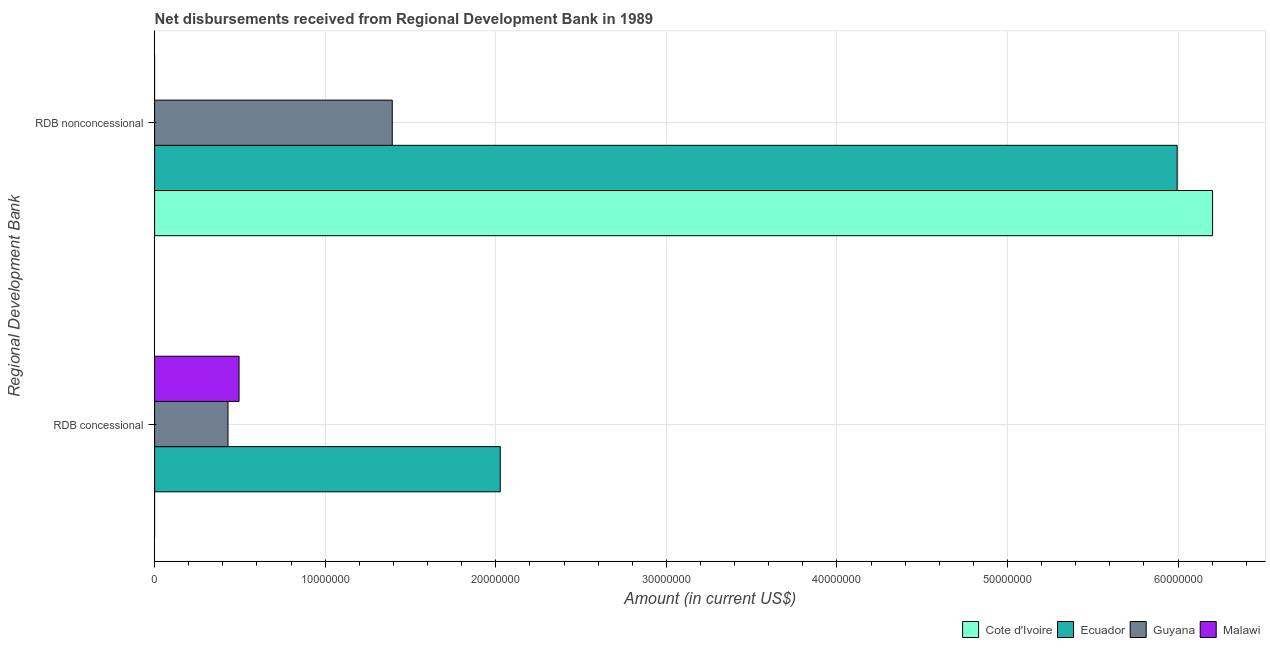Are the number of bars per tick equal to the number of legend labels?
Provide a short and direct response. No. Are the number of bars on each tick of the Y-axis equal?
Make the answer very short. Yes. What is the label of the 1st group of bars from the top?
Give a very brief answer. RDB nonconcessional. What is the net non concessional disbursements from rdb in Guyana?
Offer a very short reply. 1.39e+07. Across all countries, what is the maximum net non concessional disbursements from rdb?
Keep it short and to the point. 6.20e+07. In which country was the net concessional disbursements from rdb maximum?
Offer a very short reply. Ecuador. What is the total net non concessional disbursements from rdb in the graph?
Offer a very short reply. 1.36e+08. What is the difference between the net non concessional disbursements from rdb in Ecuador and that in Cote d'Ivoire?
Provide a short and direct response. -2.08e+06. What is the difference between the net concessional disbursements from rdb in Guyana and the net non concessional disbursements from rdb in Cote d'Ivoire?
Give a very brief answer. -5.77e+07. What is the average net concessional disbursements from rdb per country?
Offer a very short reply. 7.38e+06. What is the difference between the net non concessional disbursements from rdb and net concessional disbursements from rdb in Guyana?
Offer a terse response. 9.63e+06. What is the ratio of the net non concessional disbursements from rdb in Ecuador to that in Guyana?
Give a very brief answer. 4.3. In how many countries, is the net concessional disbursements from rdb greater than the average net concessional disbursements from rdb taken over all countries?
Make the answer very short. 1. Are all the bars in the graph horizontal?
Your response must be concise. Yes. Are the values on the major ticks of X-axis written in scientific E-notation?
Your answer should be very brief. No. Does the graph contain grids?
Make the answer very short. Yes. How many legend labels are there?
Offer a terse response. 4. How are the legend labels stacked?
Provide a short and direct response. Horizontal. What is the title of the graph?
Give a very brief answer. Net disbursements received from Regional Development Bank in 1989. What is the label or title of the X-axis?
Offer a terse response. Amount (in current US$). What is the label or title of the Y-axis?
Keep it short and to the point. Regional Development Bank. What is the Amount (in current US$) in Cote d'Ivoire in RDB concessional?
Keep it short and to the point. 0. What is the Amount (in current US$) of Ecuador in RDB concessional?
Offer a terse response. 2.03e+07. What is the Amount (in current US$) in Guyana in RDB concessional?
Offer a very short reply. 4.30e+06. What is the Amount (in current US$) in Malawi in RDB concessional?
Ensure brevity in your answer.  4.95e+06. What is the Amount (in current US$) of Cote d'Ivoire in RDB nonconcessional?
Offer a very short reply. 6.20e+07. What is the Amount (in current US$) in Ecuador in RDB nonconcessional?
Offer a terse response. 5.99e+07. What is the Amount (in current US$) of Guyana in RDB nonconcessional?
Your response must be concise. 1.39e+07. Across all Regional Development Bank, what is the maximum Amount (in current US$) in Cote d'Ivoire?
Your response must be concise. 6.20e+07. Across all Regional Development Bank, what is the maximum Amount (in current US$) in Ecuador?
Provide a short and direct response. 5.99e+07. Across all Regional Development Bank, what is the maximum Amount (in current US$) of Guyana?
Your answer should be very brief. 1.39e+07. Across all Regional Development Bank, what is the maximum Amount (in current US$) of Malawi?
Your answer should be compact. 4.95e+06. Across all Regional Development Bank, what is the minimum Amount (in current US$) of Cote d'Ivoire?
Give a very brief answer. 0. Across all Regional Development Bank, what is the minimum Amount (in current US$) in Ecuador?
Give a very brief answer. 2.03e+07. Across all Regional Development Bank, what is the minimum Amount (in current US$) in Guyana?
Provide a succinct answer. 4.30e+06. Across all Regional Development Bank, what is the minimum Amount (in current US$) of Malawi?
Your response must be concise. 0. What is the total Amount (in current US$) of Cote d'Ivoire in the graph?
Your response must be concise. 6.20e+07. What is the total Amount (in current US$) in Ecuador in the graph?
Your response must be concise. 8.02e+07. What is the total Amount (in current US$) of Guyana in the graph?
Give a very brief answer. 1.82e+07. What is the total Amount (in current US$) of Malawi in the graph?
Offer a very short reply. 4.95e+06. What is the difference between the Amount (in current US$) in Ecuador in RDB concessional and that in RDB nonconcessional?
Make the answer very short. -3.97e+07. What is the difference between the Amount (in current US$) in Guyana in RDB concessional and that in RDB nonconcessional?
Offer a terse response. -9.63e+06. What is the difference between the Amount (in current US$) of Ecuador in RDB concessional and the Amount (in current US$) of Guyana in RDB nonconcessional?
Give a very brief answer. 6.33e+06. What is the average Amount (in current US$) in Cote d'Ivoire per Regional Development Bank?
Offer a terse response. 3.10e+07. What is the average Amount (in current US$) of Ecuador per Regional Development Bank?
Provide a short and direct response. 4.01e+07. What is the average Amount (in current US$) in Guyana per Regional Development Bank?
Keep it short and to the point. 9.12e+06. What is the average Amount (in current US$) of Malawi per Regional Development Bank?
Provide a succinct answer. 2.48e+06. What is the difference between the Amount (in current US$) of Ecuador and Amount (in current US$) of Guyana in RDB concessional?
Your answer should be compact. 1.60e+07. What is the difference between the Amount (in current US$) of Ecuador and Amount (in current US$) of Malawi in RDB concessional?
Offer a terse response. 1.53e+07. What is the difference between the Amount (in current US$) in Guyana and Amount (in current US$) in Malawi in RDB concessional?
Provide a short and direct response. -6.47e+05. What is the difference between the Amount (in current US$) of Cote d'Ivoire and Amount (in current US$) of Ecuador in RDB nonconcessional?
Offer a terse response. 2.08e+06. What is the difference between the Amount (in current US$) in Cote d'Ivoire and Amount (in current US$) in Guyana in RDB nonconcessional?
Ensure brevity in your answer.  4.81e+07. What is the difference between the Amount (in current US$) of Ecuador and Amount (in current US$) of Guyana in RDB nonconcessional?
Make the answer very short. 4.60e+07. What is the ratio of the Amount (in current US$) in Ecuador in RDB concessional to that in RDB nonconcessional?
Make the answer very short. 0.34. What is the ratio of the Amount (in current US$) in Guyana in RDB concessional to that in RDB nonconcessional?
Your response must be concise. 0.31. What is the difference between the highest and the second highest Amount (in current US$) of Ecuador?
Ensure brevity in your answer.  3.97e+07. What is the difference between the highest and the second highest Amount (in current US$) of Guyana?
Offer a very short reply. 9.63e+06. What is the difference between the highest and the lowest Amount (in current US$) in Cote d'Ivoire?
Your response must be concise. 6.20e+07. What is the difference between the highest and the lowest Amount (in current US$) in Ecuador?
Your answer should be compact. 3.97e+07. What is the difference between the highest and the lowest Amount (in current US$) of Guyana?
Your answer should be very brief. 9.63e+06. What is the difference between the highest and the lowest Amount (in current US$) of Malawi?
Provide a succinct answer. 4.95e+06. 